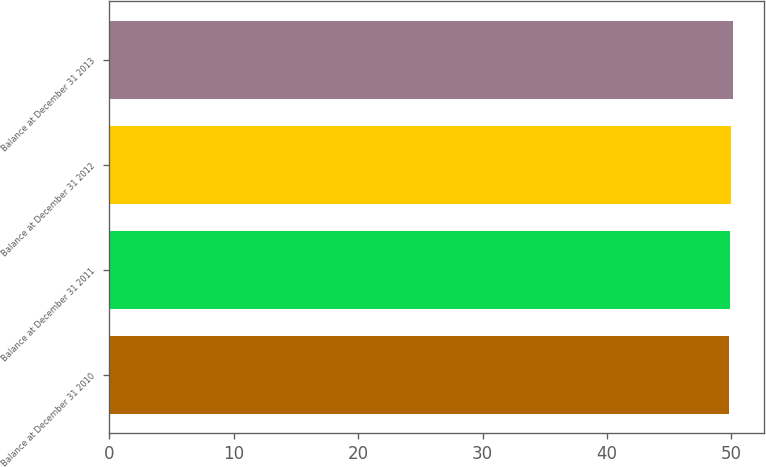Convert chart. <chart><loc_0><loc_0><loc_500><loc_500><bar_chart><fcel>Balance at December 31 2010<fcel>Balance at December 31 2011<fcel>Balance at December 31 2012<fcel>Balance at December 31 2013<nl><fcel>49.8<fcel>49.9<fcel>50<fcel>50.1<nl></chart> 